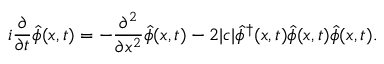Convert formula to latex. <formula><loc_0><loc_0><loc_500><loc_500>i \frac { \partial } { \partial t } \hat { \phi } ( x , t ) = - \frac { \partial ^ { 2 } } { \partial x ^ { 2 } } \hat { \phi } ( x , t ) - 2 | c | \hat { \phi } ^ { \dagger } ( x , t ) \hat { \phi } ( x , t ) \hat { \phi } ( x , t ) .</formula> 